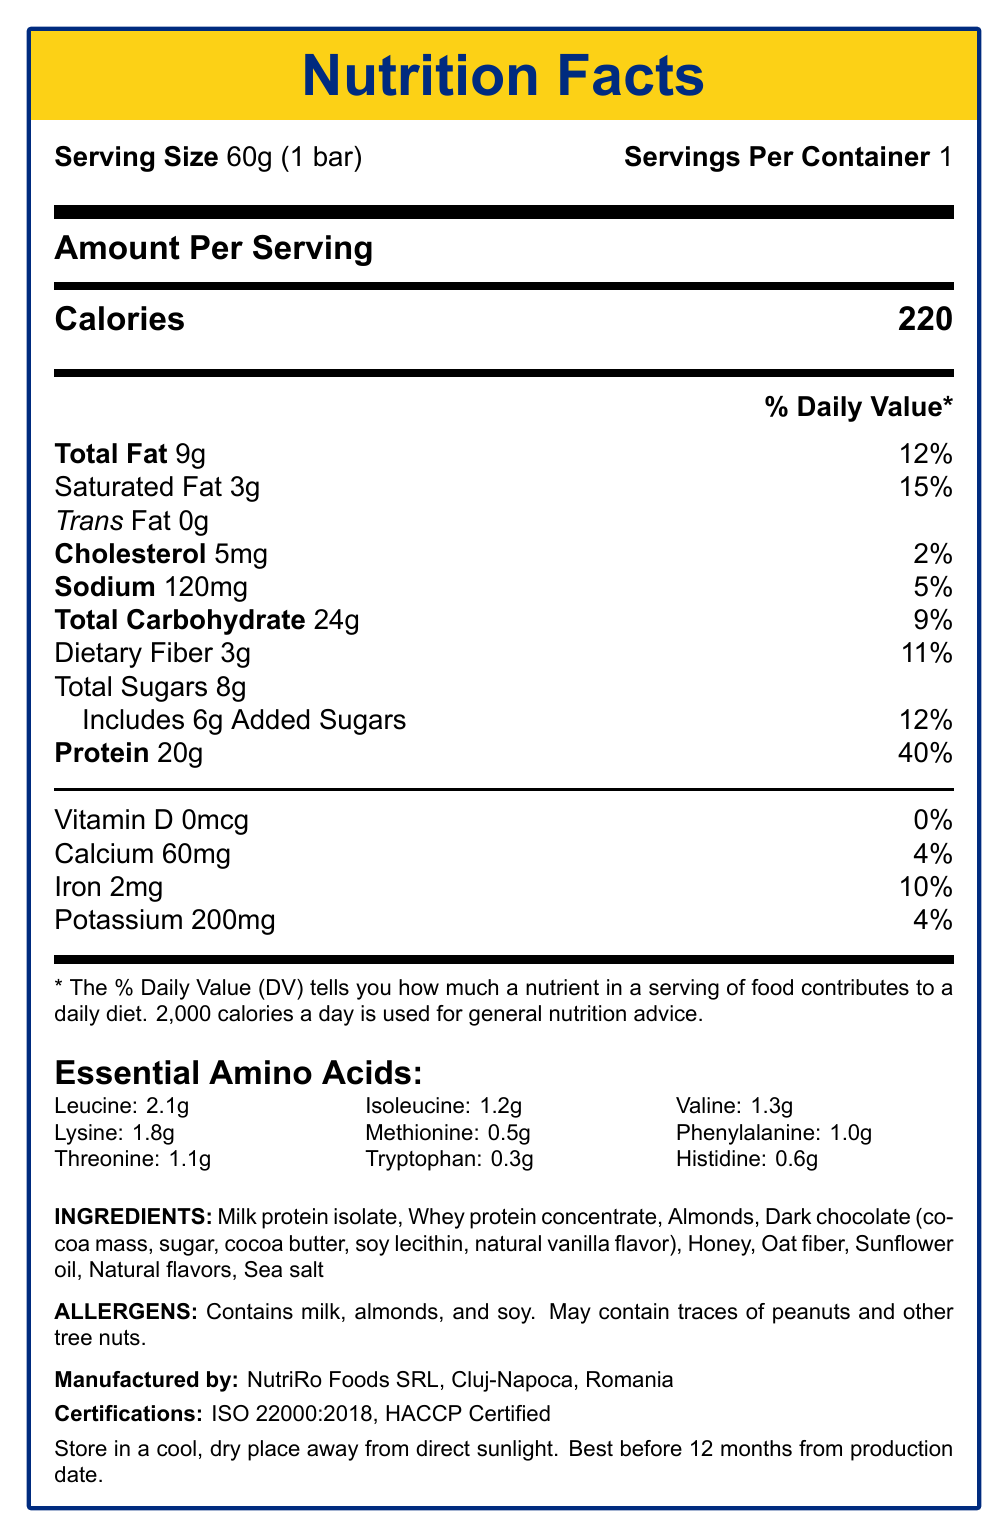How much protein does one serving of the ProteRo Fitness Bar contain? The document states that one serving contains 20g of protein.
Answer: 20g By what percentage does one bar fulfill the daily value for protein? The document mentions that the protein content in one bar is 20g, which is 40% of the daily value.
Answer: 40% Which amino acid is present in the highest amount in the ProteRo Fitness Bar? The essential amino acids section shows that Leucine is present in the highest quantity at 2.1g.
Answer: Leucine What is the serving size for the ProteRo Fitness Bar? The document lists the serving size at the very top as 60g, which is equivalent to 1 bar.
Answer: 60g (1 bar) How many calories does one bar of ProteRo Fitness Bar provide? The document states that one serving of the bar provides 220 calories.
Answer: 220 Does the ProteRo Fitness Bar contain any cholesterol? The nutritional information indicates that it contains 5mg of cholesterol.
Answer: Yes What are the storage instructions for this protein bar? The storage instructions clearly state to store it in a cool, dry place away from direct sunlight.
Answer: Store in a cool, dry place away from direct sunlight Which certification does NutriRo Foods SRL hold? A. ISO 9001 B. HACCP Certified C. ISO 22000:2018 D. Both B and C The certifications section lists both ISO 22000:2018 and HACCP Certifications.
Answer: D What is the daily value percentage for saturated fat in this bar? A. 5% B. 10% C. 15% D. 20% The document shows that the saturated fat content of 3g corresponds to 15% of the daily value.
Answer: C. 15% Can this bar be used as a meal replacement for inactive individuals? The recommended use suggests it is ideal as a post-workout snack or meal replacement specifically for active individuals.
Answer: No Summarize the main content of the document. The document is essentially a comprehensive nutrition facts label for the ProteRo Fitness Bar, targeting fitness enthusiasts, athletes, and health-conscious consumers in Romania.
Answer: The document provides the nutritional facts for the ProteRo Fitness Bar, detailing its serving size, the amount of calories, total fat, carbohydrates, protein, and essential amino acids. It also lists the ingredients, allergens, manufacturer details, certifications, storage instructions, and recommended use. What is the amount of potassium in one serving? The nutritional breakdown lists the potassium content as 200mg per serving.
Answer: 200mg What ingredients contribute to the protein content? The ingredients section specifies milk protein isolate and whey protein concentrate as protein sources.
Answer: Milk protein isolate, Whey protein concentrate What percentage of the daily value is provided by iron in one serving of the bar? The iron content per serving is 2mg, which equals 10% of the daily value.
Answer: 10% What is the flavoring agent listed in the dark chocolate ingredient? The ingredients list shows that the dark chocolate contains natural vanilla flavor.
Answer: Natural vanilla flavor How many grams of added sugars does the bar contain? The nutritional information section for total carbohydrates states that it includes 6g of added sugars.
Answer: 6g For which audience is the ProteRo Fitness Bar most suitable? The target audience is specified toward the end of the document.
Answer: Fitness enthusiasts, athletes, and health-conscious consumers in Romania Is there any trans fat present in the ProteRo Fitness Bar? The document shows 0g trans fat, indicating the absence of trans fats.
Answer: No Does the document specify the production date for the product? The document mentions the expiration date is 12 months from the production date but does not provide the exact production date itself.
Answer: Not enough information 